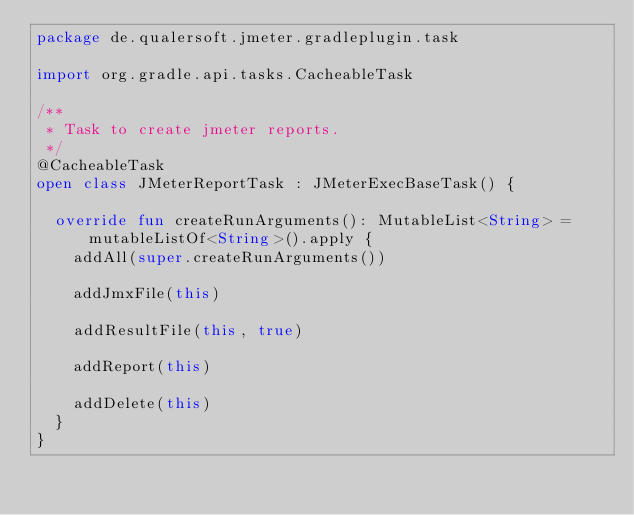<code> <loc_0><loc_0><loc_500><loc_500><_Kotlin_>package de.qualersoft.jmeter.gradleplugin.task

import org.gradle.api.tasks.CacheableTask

/**
 * Task to create jmeter reports.
 */
@CacheableTask
open class JMeterReportTask : JMeterExecBaseTask() {

  override fun createRunArguments(): MutableList<String> = mutableListOf<String>().apply {
    addAll(super.createRunArguments())

    addJmxFile(this)

    addResultFile(this, true)

    addReport(this)

    addDelete(this)
  }
}
</code> 